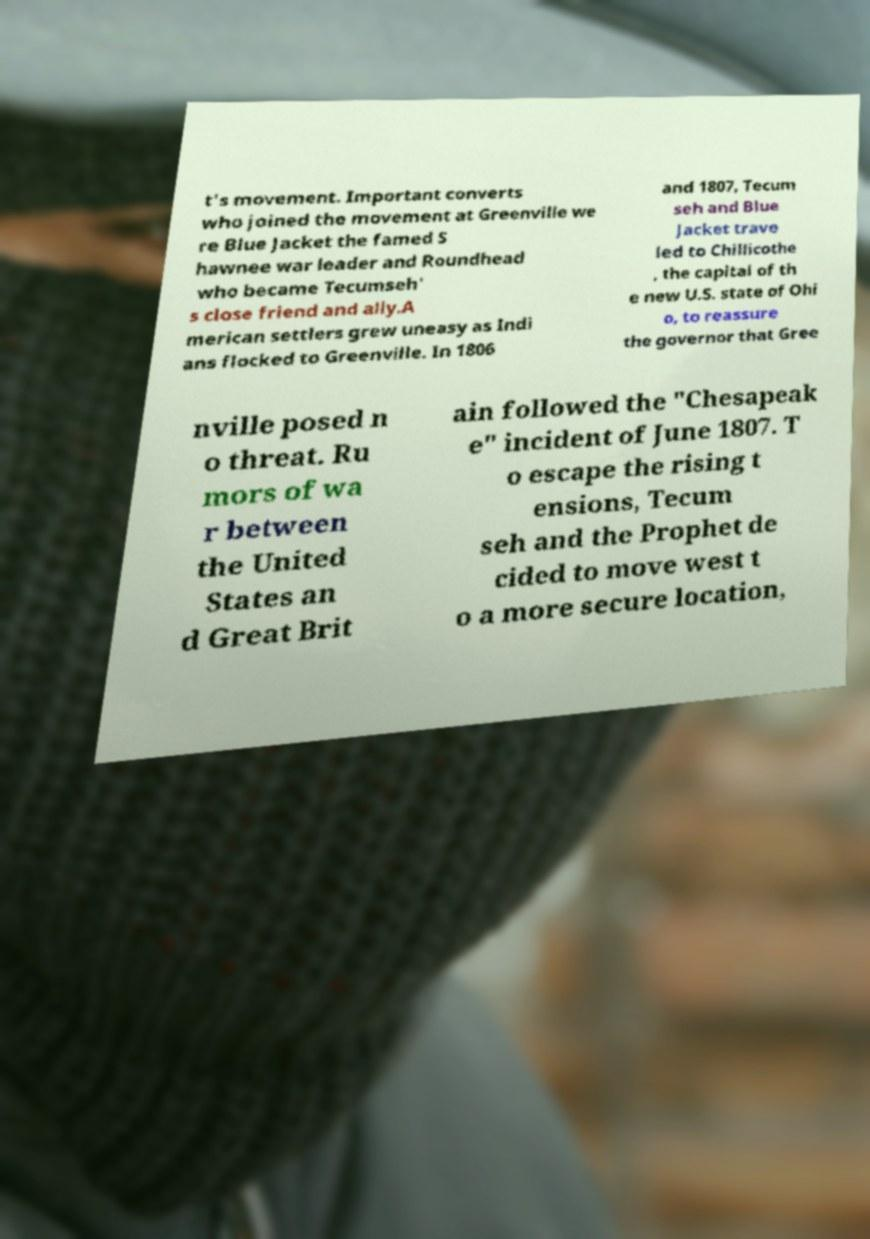Could you assist in decoding the text presented in this image and type it out clearly? t's movement. Important converts who joined the movement at Greenville we re Blue Jacket the famed S hawnee war leader and Roundhead who became Tecumseh' s close friend and ally.A merican settlers grew uneasy as Indi ans flocked to Greenville. In 1806 and 1807, Tecum seh and Blue Jacket trave led to Chillicothe , the capital of th e new U.S. state of Ohi o, to reassure the governor that Gree nville posed n o threat. Ru mors of wa r between the United States an d Great Brit ain followed the "Chesapeak e" incident of June 1807. T o escape the rising t ensions, Tecum seh and the Prophet de cided to move west t o a more secure location, 